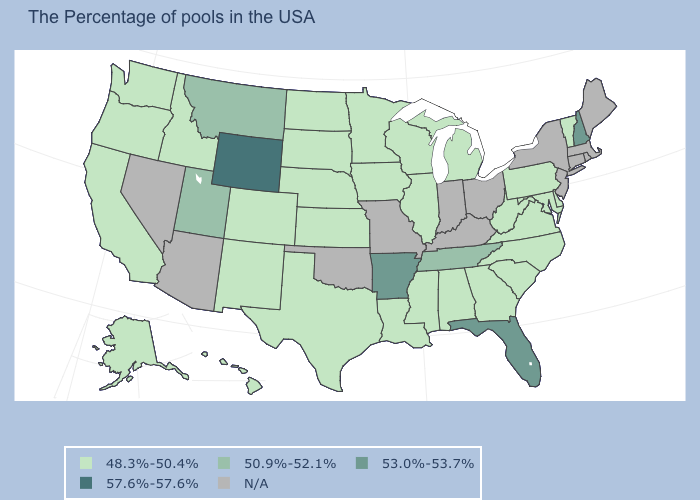What is the value of Nevada?
Write a very short answer. N/A. Which states have the highest value in the USA?
Short answer required. Wyoming. What is the value of Arizona?
Be succinct. N/A. Which states have the lowest value in the South?
Give a very brief answer. Delaware, Maryland, Virginia, North Carolina, South Carolina, West Virginia, Georgia, Alabama, Mississippi, Louisiana, Texas. Does the map have missing data?
Be succinct. Yes. Which states have the highest value in the USA?
Answer briefly. Wyoming. Name the states that have a value in the range 57.6%-57.6%?
Answer briefly. Wyoming. Name the states that have a value in the range 57.6%-57.6%?
Keep it brief. Wyoming. What is the value of Missouri?
Write a very short answer. N/A. Does New Hampshire have the lowest value in the Northeast?
Give a very brief answer. No. Name the states that have a value in the range 48.3%-50.4%?
Keep it brief. Vermont, Delaware, Maryland, Pennsylvania, Virginia, North Carolina, South Carolina, West Virginia, Georgia, Michigan, Alabama, Wisconsin, Illinois, Mississippi, Louisiana, Minnesota, Iowa, Kansas, Nebraska, Texas, South Dakota, North Dakota, Colorado, New Mexico, Idaho, California, Washington, Oregon, Alaska, Hawaii. What is the value of Tennessee?
Quick response, please. 50.9%-52.1%. Name the states that have a value in the range 50.9%-52.1%?
Keep it brief. Tennessee, Utah, Montana. 